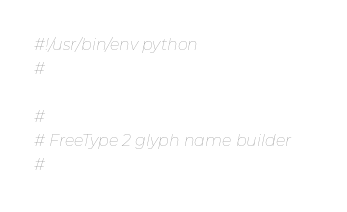<code> <loc_0><loc_0><loc_500><loc_500><_Python_>#!/usr/bin/env python
#

#
# FreeType 2 glyph name builder
#

</code> 